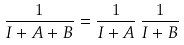Convert formula to latex. <formula><loc_0><loc_0><loc_500><loc_500>\frac { 1 } { I + A + B } = \frac { 1 } { I + A } \, \frac { 1 } { I + B }</formula> 